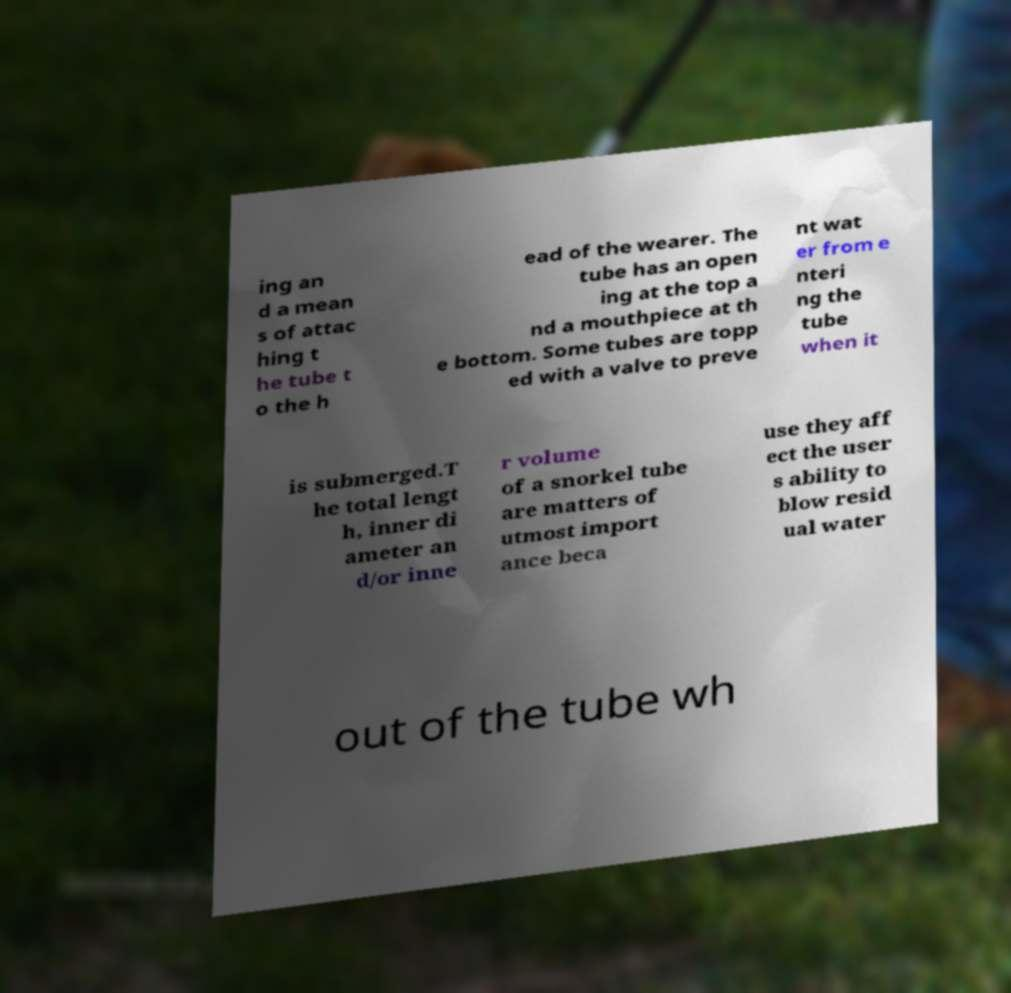What messages or text are displayed in this image? I need them in a readable, typed format. ing an d a mean s of attac hing t he tube t o the h ead of the wearer. The tube has an open ing at the top a nd a mouthpiece at th e bottom. Some tubes are topp ed with a valve to preve nt wat er from e nteri ng the tube when it is submerged.T he total lengt h, inner di ameter an d/or inne r volume of a snorkel tube are matters of utmost import ance beca use they aff ect the user s ability to blow resid ual water out of the tube wh 